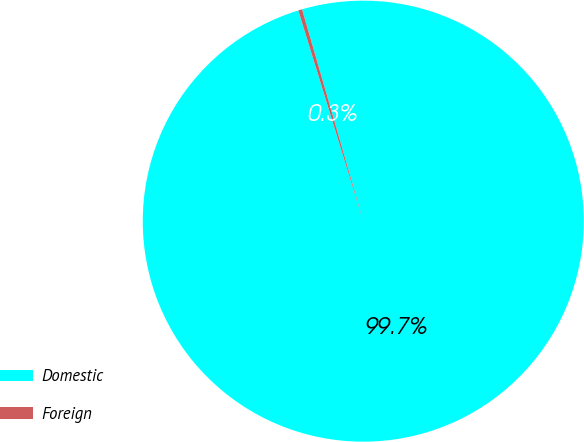<chart> <loc_0><loc_0><loc_500><loc_500><pie_chart><fcel>Domestic<fcel>Foreign<nl><fcel>99.72%<fcel>0.28%<nl></chart> 